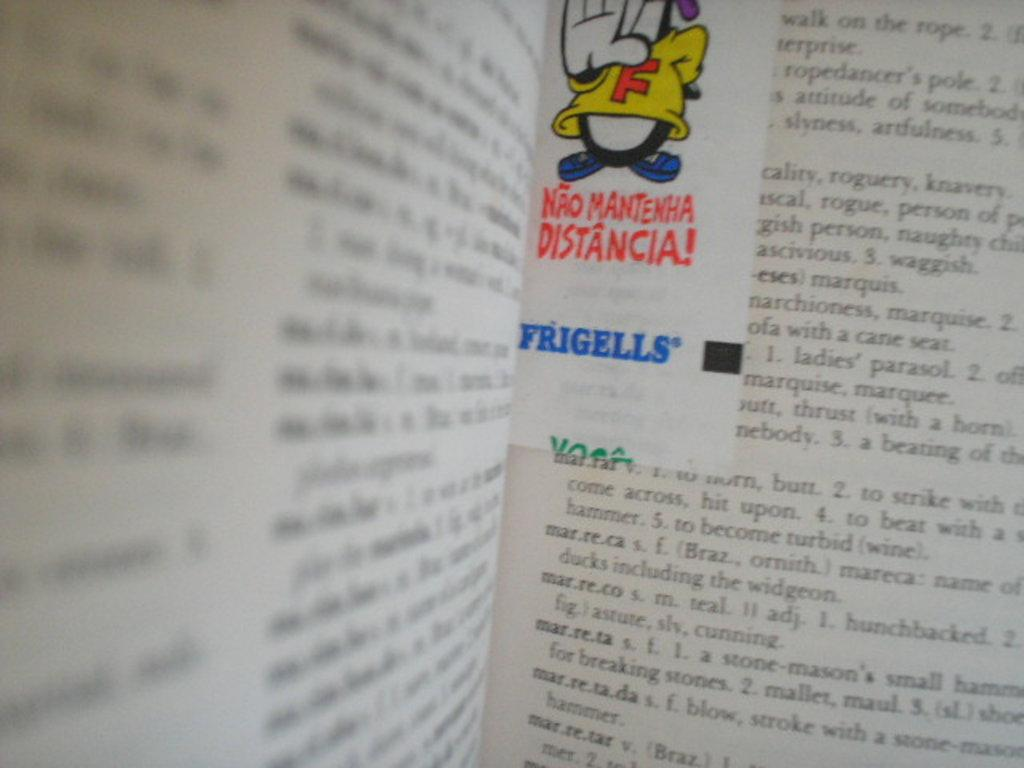<image>
Summarize the visual content of the image. a book with the word Frigells in it 